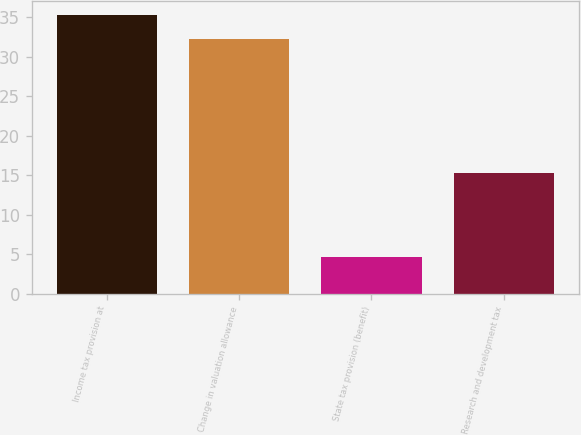<chart> <loc_0><loc_0><loc_500><loc_500><bar_chart><fcel>Income tax provision at<fcel>Change in valuation allowance<fcel>State tax provision (benefit)<fcel>Research and development tax<nl><fcel>35.24<fcel>32.2<fcel>4.6<fcel>15.3<nl></chart> 